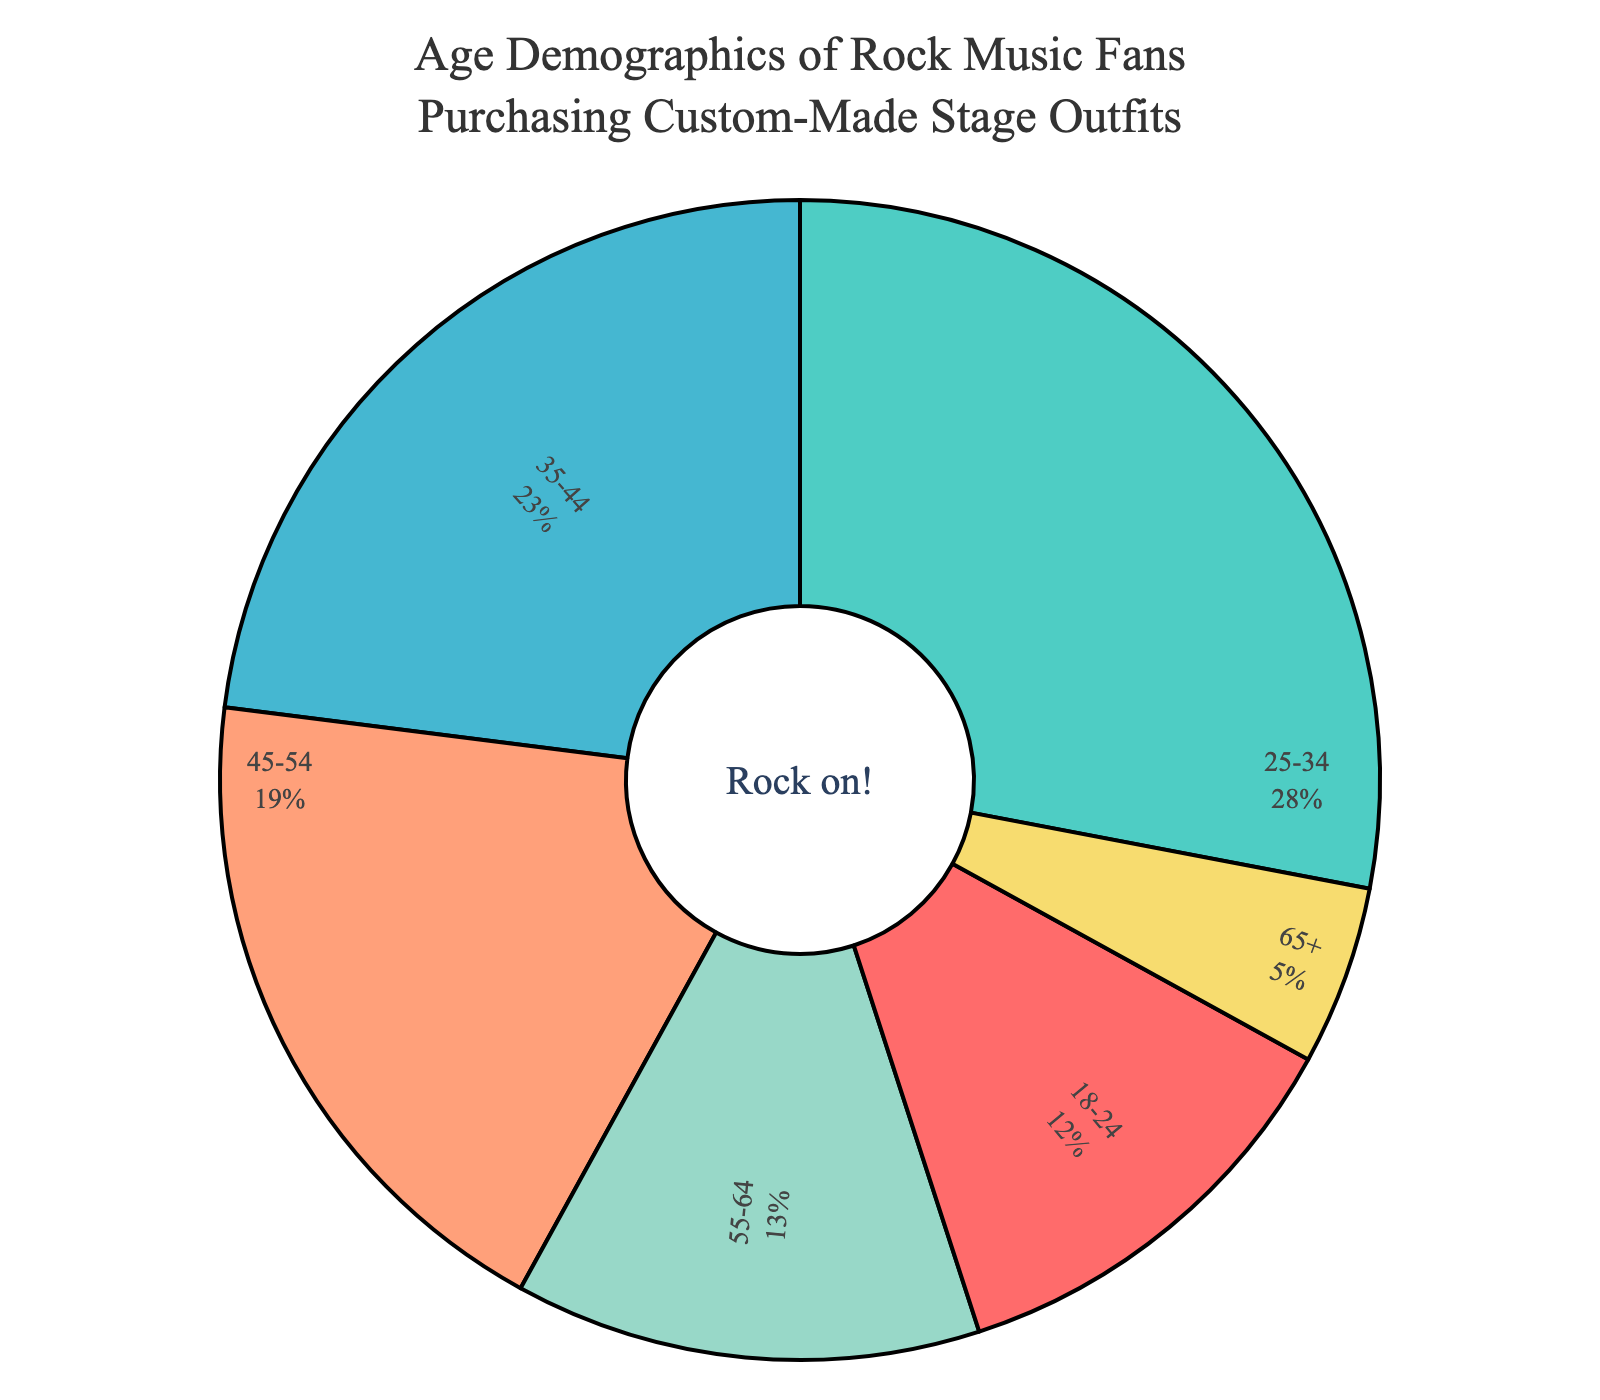Which age group has the highest percentage of rock music fans purchasing custom-made stage outfits? Look at the figure and identify the age group with the largest segment. The 25-34 age group has the highest percentage.
Answer: 25-34 What percentage of rock music fans purchasing custom-made stage outfits are aged 45 and above? Add the percentages of the 45-54, 55-64, and 65+ age groups: 19% + 13% + 5% = 37%.
Answer: 37% Is the percentage of rock music fans purchasing custom-made stage outfits higher for ages 25-34 or 35-44? Compare the percentages for the 25-34 and 35-44 age groups. The 25-34 age group has 28%, and the 35-44 age group has 23%.
Answer: 25-34 What is the combined percentage of rock music fans purchasing custom-made stage outfits who are under 35? Add the percentages for the 18-24 and 25-34 age groups: 12% + 28% = 40%.
Answer: 40% What is the visual difference in size between the segments for age groups 18-24 and 65+? The 18-24 segment appears about twice the size of the 65+ segment. The 18-24 segment is 12%, and the 65+ segment is 5%.
Answer: Twice as large Which color is used to represent the 35-44 age group in the pie chart? Identify the segment representing the 35-44 age group and note its color. The 35-44 age group is marked in a bluish color.
Answer: Blue What is the sum of the percentages for the age groups 18-24 and 55-64? Add the percentages for the 18-24 and 55-64 age groups: 12% + 13% = 25%.
Answer: 25% Is the percentage of rock music fans purchasing custom-made stage outfits greater for the 45-54 age group or the 55-64 age group? Compare the percentages for the 45-54 and 55-64 age groups. The 45-54 age group has 19%, and the 55-64 age group has 13%.
Answer: 45-54 What age group represents the smallest segment in the pie chart? Identify the smallest segment in the chart. The 65+ age group represents the smallest segment with 5%.
Answer: 65+ 